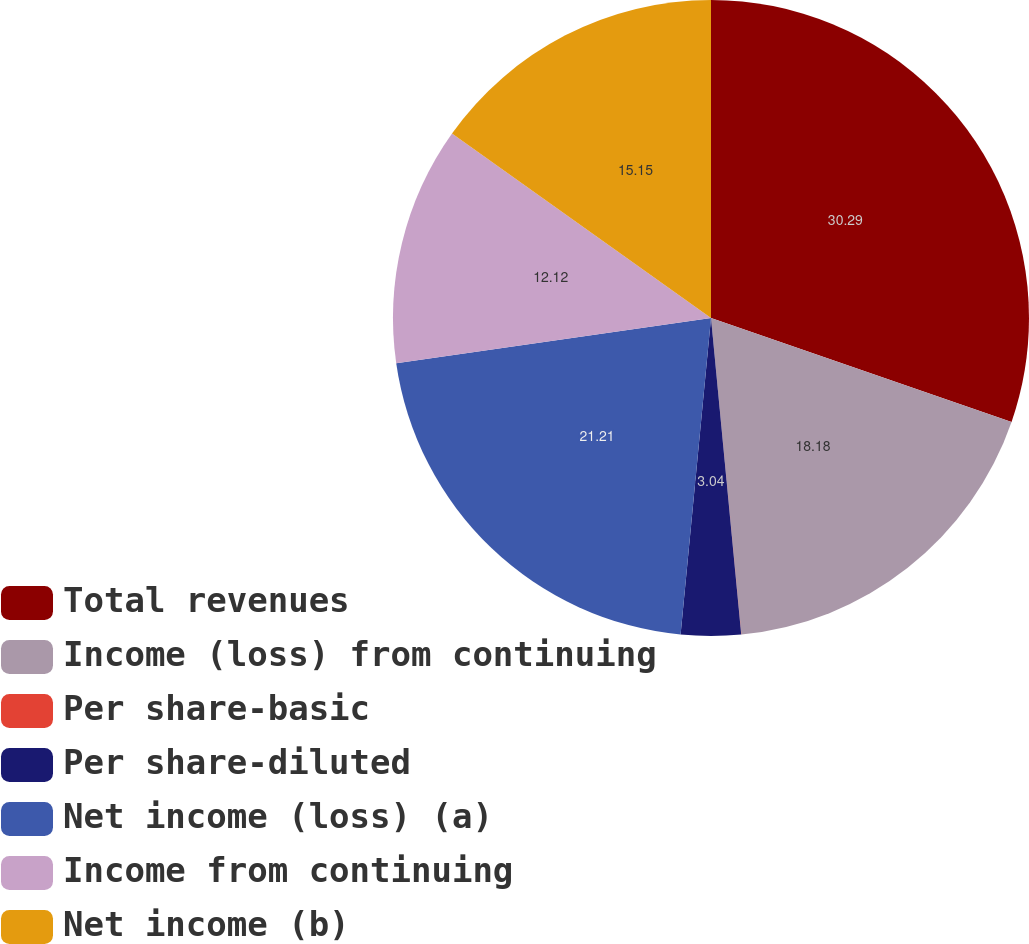Convert chart to OTSL. <chart><loc_0><loc_0><loc_500><loc_500><pie_chart><fcel>Total revenues<fcel>Income (loss) from continuing<fcel>Per share-basic<fcel>Per share-diluted<fcel>Net income (loss) (a)<fcel>Income from continuing<fcel>Net income (b)<nl><fcel>30.3%<fcel>18.18%<fcel>0.01%<fcel>3.04%<fcel>21.21%<fcel>12.12%<fcel>15.15%<nl></chart> 